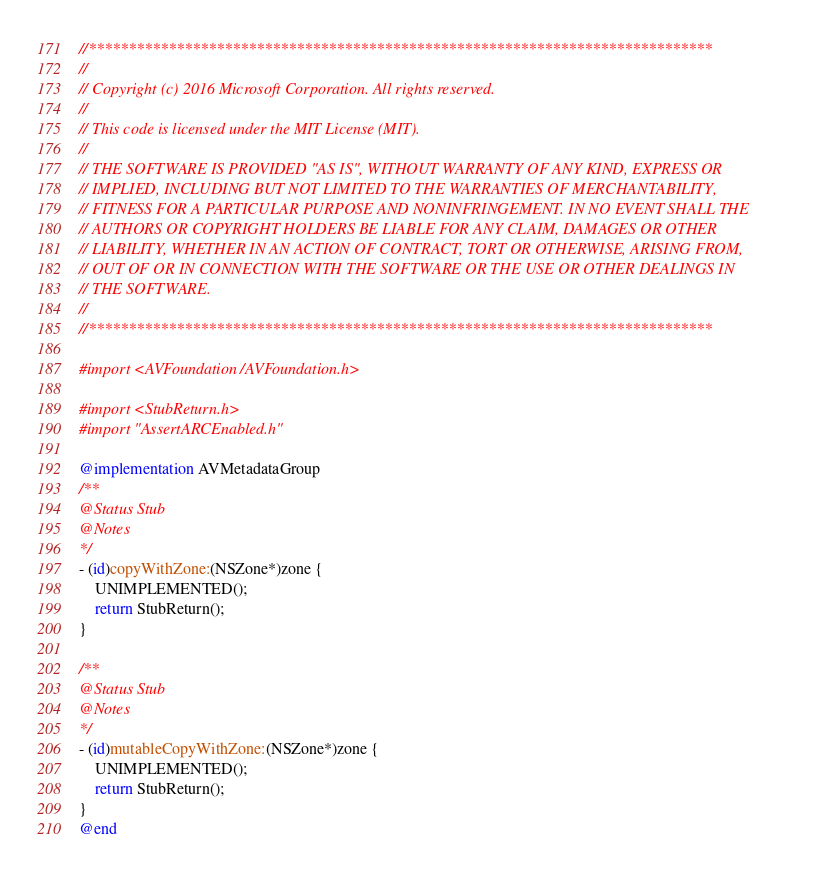<code> <loc_0><loc_0><loc_500><loc_500><_ObjectiveC_>//******************************************************************************
//
// Copyright (c) 2016 Microsoft Corporation. All rights reserved.
//
// This code is licensed under the MIT License (MIT).
//
// THE SOFTWARE IS PROVIDED "AS IS", WITHOUT WARRANTY OF ANY KIND, EXPRESS OR
// IMPLIED, INCLUDING BUT NOT LIMITED TO THE WARRANTIES OF MERCHANTABILITY,
// FITNESS FOR A PARTICULAR PURPOSE AND NONINFRINGEMENT. IN NO EVENT SHALL THE
// AUTHORS OR COPYRIGHT HOLDERS BE LIABLE FOR ANY CLAIM, DAMAGES OR OTHER
// LIABILITY, WHETHER IN AN ACTION OF CONTRACT, TORT OR OTHERWISE, ARISING FROM,
// OUT OF OR IN CONNECTION WITH THE SOFTWARE OR THE USE OR OTHER DEALINGS IN
// THE SOFTWARE.
//
//******************************************************************************

#import <AVFoundation/AVFoundation.h>

#import <StubReturn.h>
#import "AssertARCEnabled.h"

@implementation AVMetadataGroup
/**
@Status Stub
@Notes
*/
- (id)copyWithZone:(NSZone*)zone {
    UNIMPLEMENTED();
    return StubReturn();
}

/**
@Status Stub
@Notes
*/
- (id)mutableCopyWithZone:(NSZone*)zone {
    UNIMPLEMENTED();
    return StubReturn();
}
@end
</code> 